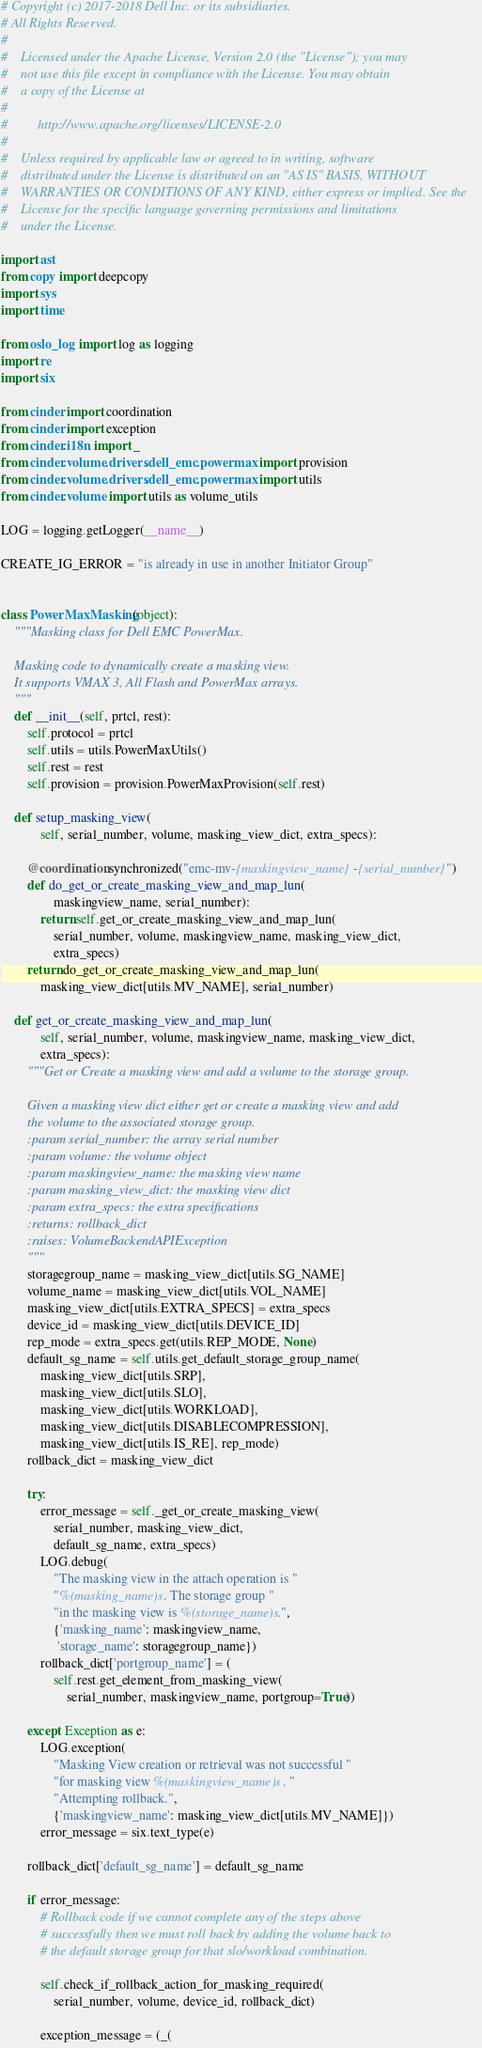<code> <loc_0><loc_0><loc_500><loc_500><_Python_># Copyright (c) 2017-2018 Dell Inc. or its subsidiaries.
# All Rights Reserved.
#
#    Licensed under the Apache License, Version 2.0 (the "License"); you may
#    not use this file except in compliance with the License. You may obtain
#    a copy of the License at
#
#         http://www.apache.org/licenses/LICENSE-2.0
#
#    Unless required by applicable law or agreed to in writing, software
#    distributed under the License is distributed on an "AS IS" BASIS, WITHOUT
#    WARRANTIES OR CONDITIONS OF ANY KIND, either express or implied. See the
#    License for the specific language governing permissions and limitations
#    under the License.

import ast
from copy import deepcopy
import sys
import time

from oslo_log import log as logging
import re
import six

from cinder import coordination
from cinder import exception
from cinder.i18n import _
from cinder.volume.drivers.dell_emc.powermax import provision
from cinder.volume.drivers.dell_emc.powermax import utils
from cinder.volume import utils as volume_utils

LOG = logging.getLogger(__name__)

CREATE_IG_ERROR = "is already in use in another Initiator Group"


class PowerMaxMasking(object):
    """Masking class for Dell EMC PowerMax.

    Masking code to dynamically create a masking view.
    It supports VMAX 3, All Flash and PowerMax arrays.
    """
    def __init__(self, prtcl, rest):
        self.protocol = prtcl
        self.utils = utils.PowerMaxUtils()
        self.rest = rest
        self.provision = provision.PowerMaxProvision(self.rest)

    def setup_masking_view(
            self, serial_number, volume, masking_view_dict, extra_specs):

        @coordination.synchronized("emc-mv-{maskingview_name}-{serial_number}")
        def do_get_or_create_masking_view_and_map_lun(
                maskingview_name, serial_number):
            return self.get_or_create_masking_view_and_map_lun(
                serial_number, volume, maskingview_name, masking_view_dict,
                extra_specs)
        return do_get_or_create_masking_view_and_map_lun(
            masking_view_dict[utils.MV_NAME], serial_number)

    def get_or_create_masking_view_and_map_lun(
            self, serial_number, volume, maskingview_name, masking_view_dict,
            extra_specs):
        """Get or Create a masking view and add a volume to the storage group.

        Given a masking view dict either get or create a masking view and add
        the volume to the associated storage group.
        :param serial_number: the array serial number
        :param volume: the volume object
        :param maskingview_name: the masking view name
        :param masking_view_dict: the masking view dict
        :param extra_specs: the extra specifications
        :returns: rollback_dict
        :raises: VolumeBackendAPIException
        """
        storagegroup_name = masking_view_dict[utils.SG_NAME]
        volume_name = masking_view_dict[utils.VOL_NAME]
        masking_view_dict[utils.EXTRA_SPECS] = extra_specs
        device_id = masking_view_dict[utils.DEVICE_ID]
        rep_mode = extra_specs.get(utils.REP_MODE, None)
        default_sg_name = self.utils.get_default_storage_group_name(
            masking_view_dict[utils.SRP],
            masking_view_dict[utils.SLO],
            masking_view_dict[utils.WORKLOAD],
            masking_view_dict[utils.DISABLECOMPRESSION],
            masking_view_dict[utils.IS_RE], rep_mode)
        rollback_dict = masking_view_dict

        try:
            error_message = self._get_or_create_masking_view(
                serial_number, masking_view_dict,
                default_sg_name, extra_specs)
            LOG.debug(
                "The masking view in the attach operation is "
                "%(masking_name)s. The storage group "
                "in the masking view is %(storage_name)s.",
                {'masking_name': maskingview_name,
                 'storage_name': storagegroup_name})
            rollback_dict['portgroup_name'] = (
                self.rest.get_element_from_masking_view(
                    serial_number, maskingview_name, portgroup=True))

        except Exception as e:
            LOG.exception(
                "Masking View creation or retrieval was not successful "
                "for masking view %(maskingview_name)s. "
                "Attempting rollback.",
                {'maskingview_name': masking_view_dict[utils.MV_NAME]})
            error_message = six.text_type(e)

        rollback_dict['default_sg_name'] = default_sg_name

        if error_message:
            # Rollback code if we cannot complete any of the steps above
            # successfully then we must roll back by adding the volume back to
            # the default storage group for that slo/workload combination.

            self.check_if_rollback_action_for_masking_required(
                serial_number, volume, device_id, rollback_dict)

            exception_message = (_(</code> 